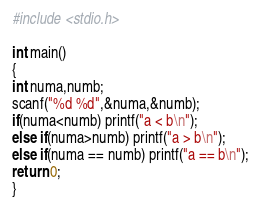Convert code to text. <code><loc_0><loc_0><loc_500><loc_500><_C_>#include <stdio.h>

int main()
{
int numa,numb;
scanf("%d %d",&numa,&numb);
if(numa<numb) printf("a < b\n");
else if(numa>numb) printf("a > b\n");
else if(numa == numb) printf("a == b\n");
return 0;
}</code> 